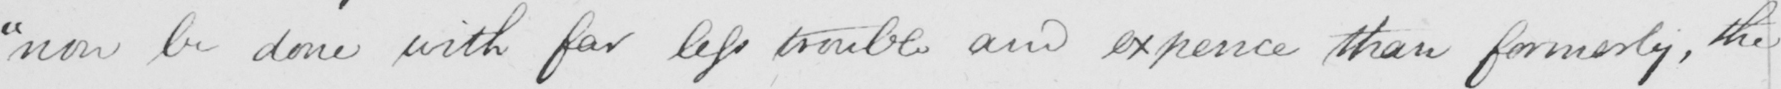What is written in this line of handwriting? "now be done with far less trouble and expence than formerly, the 